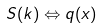<formula> <loc_0><loc_0><loc_500><loc_500>S ( k ) \Leftrightarrow q ( x )</formula> 